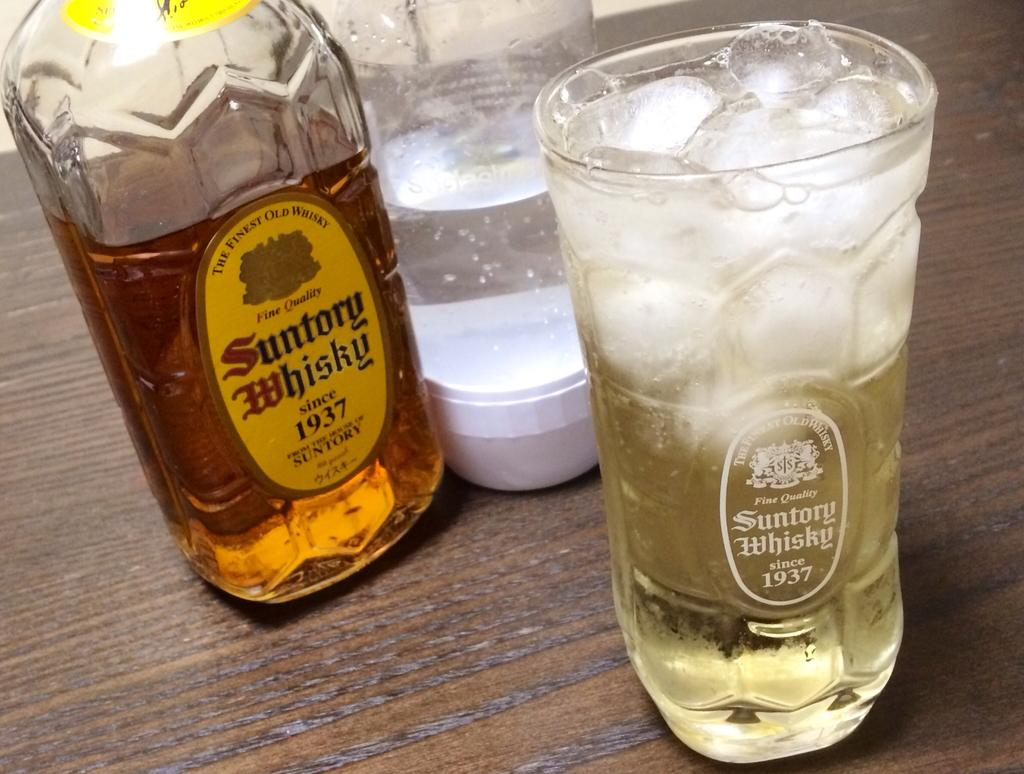Provide a one-sentence caption for the provided image. Glass and bottle of Suntory Whisky poured over cold ice on a table. 